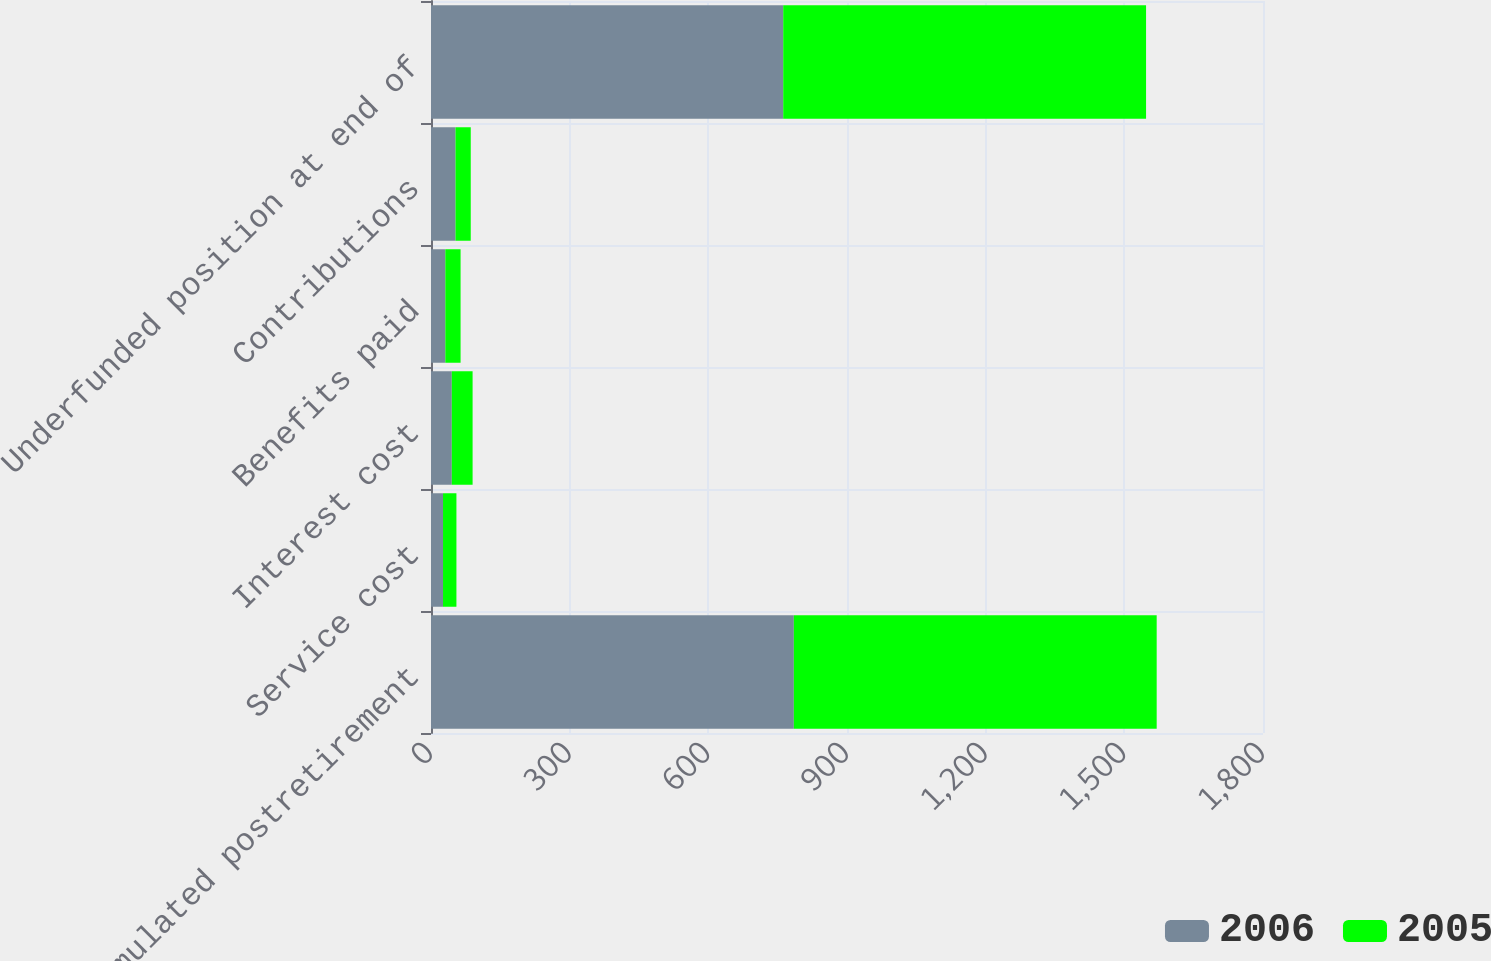Convert chart. <chart><loc_0><loc_0><loc_500><loc_500><stacked_bar_chart><ecel><fcel>Accumulated postretirement<fcel>Service cost<fcel>Interest cost<fcel>Benefits paid<fcel>Contributions<fcel>Underfunded position at end of<nl><fcel>2006<fcel>785<fcel>26<fcel>45<fcel>31<fcel>53<fcel>762<nl><fcel>2005<fcel>785<fcel>29<fcel>45<fcel>33<fcel>33<fcel>785<nl></chart> 